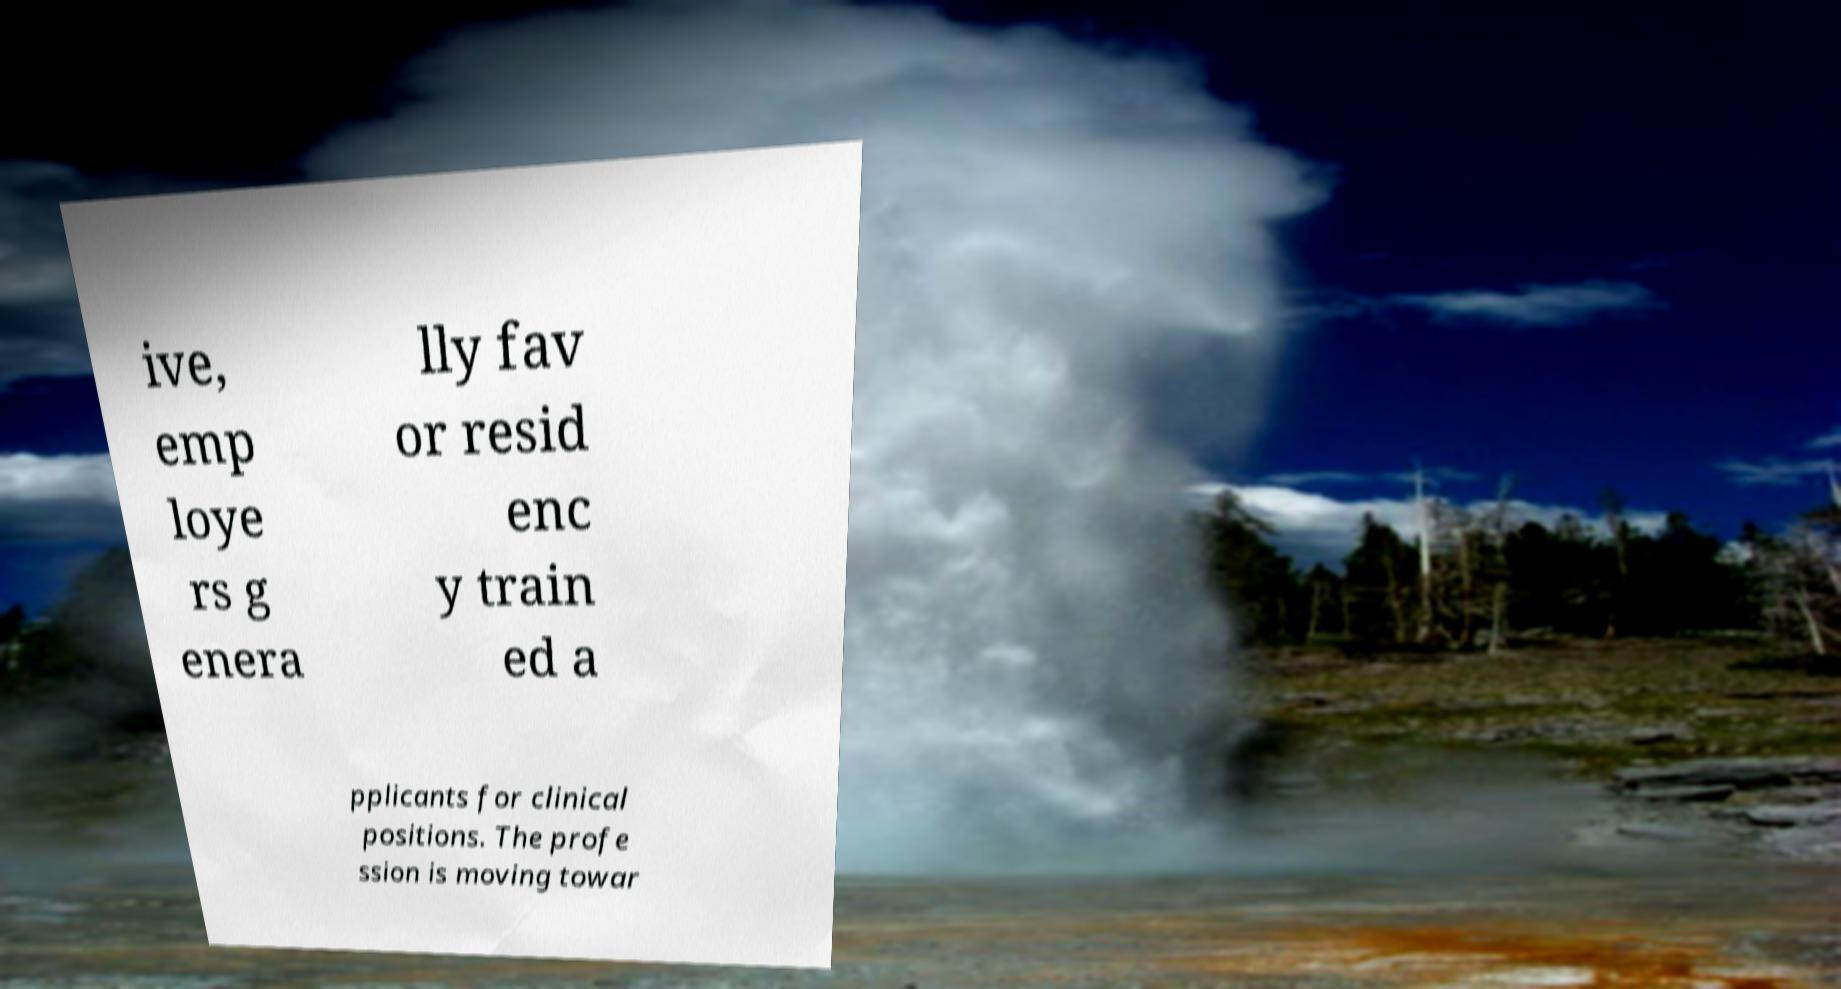Could you extract and type out the text from this image? ive, emp loye rs g enera lly fav or resid enc y train ed a pplicants for clinical positions. The profe ssion is moving towar 